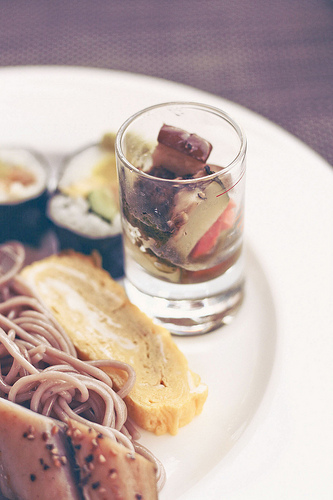<image>
Is the chocolate in front of the bread? No. The chocolate is not in front of the bread. The spatial positioning shows a different relationship between these objects. 